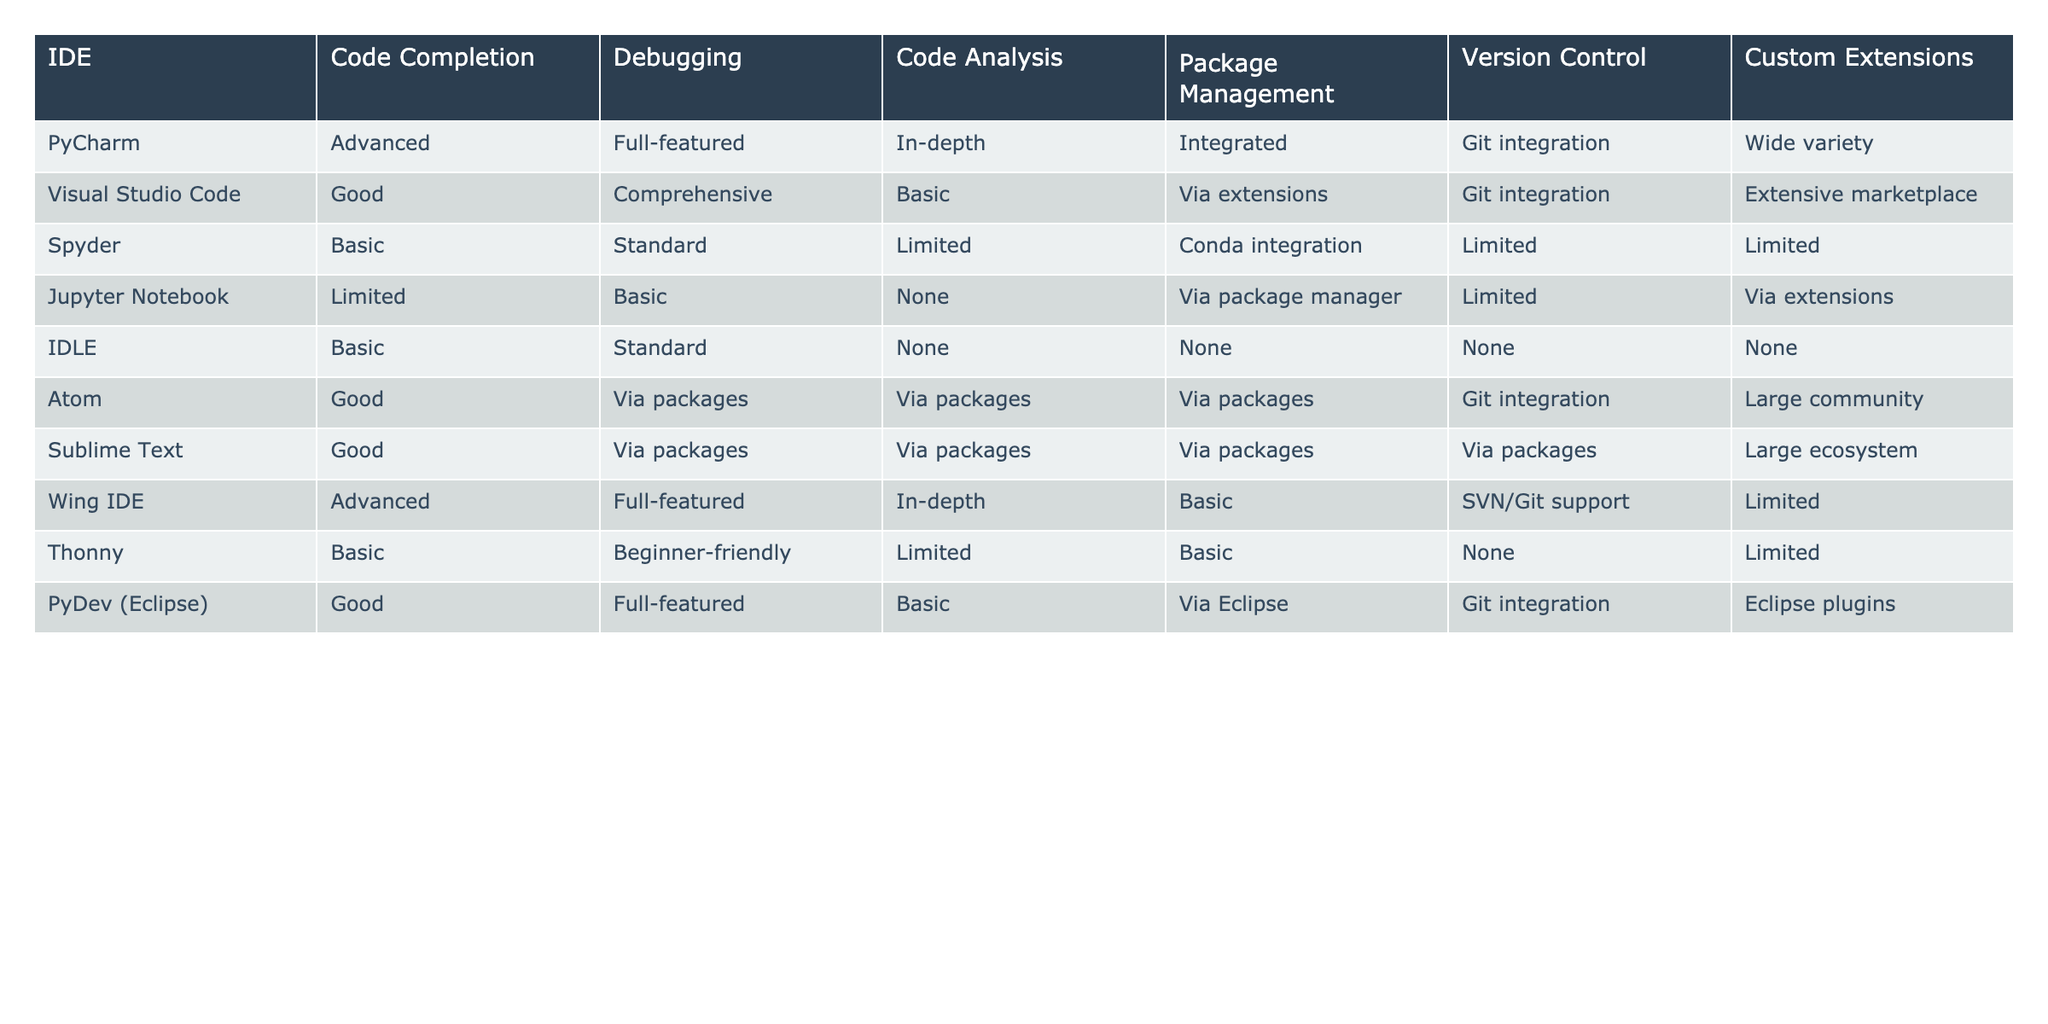What IDE has the most advanced code completion feature? From the table, PyCharm and Wing IDE both have "Advanced" code completion features. Therefore, they are the only IDEs with the most advanced feature.
Answer: PyCharm, Wing IDE Which IDE has the least code analysis capability? By examining the "Code Analysis" column, Spyder, Jupyter Notebook, IDLE, and Thonny all have "Limited" or "None" capabilities. Among these, Jupyter Notebook and IDLE have "None", indicating the lowest capability.
Answer: Jupyter Notebook, IDLE Does Atom support version control? The table shows that Atom has "Git integration" in the version control feature, meaning it supports version control.
Answer: Yes How many IDEs offer integrated package management? The table indicates that PyCharm, Spyder, Atom, and Sublime Text offer integrated package management. Counting these gives us a total of four IDEs with this feature.
Answer: 4 Which IDEs provide full-featured debugging? From the "Debugging" column, PyCharm and Wing IDE are marked as "Full-featured" for debugging. Therefore, they are the IDEs that provide this level of debugging.
Answer: PyCharm, Wing IDE What is the average capability level of code completion among the IDEs listed? The code completion capabilities among the IDEs are categorized as Advanced, Good, Basic, and Limited. Assigning values (Advanced=4, Good=3, Basic=2, Limited=1), we can calculate: (4 + 3 + 2 + 1 + 1 + 3 + 3 + 2 + 4 + 2)/10 = 2.5, which means the average is between Basic and Good.
Answer: 2.5 Is there any IDE that combines both advanced code completion and full-featured debugging? By reviewing the table, PyCharm and Wing IDE both have "Advanced" in code completion and "Full-featured" in debugging. This confirms that these IDEs combine both capabilities.
Answer: Yes How many IDEs have limited custom extensions? The custom extensions capabilities in the table show that Spyder, Jupyter Notebook, Thonny, and Wing IDE provide "Limited" custom extensions. Counting these reveals four IDEs with limited custom extensions.
Answer: 4 